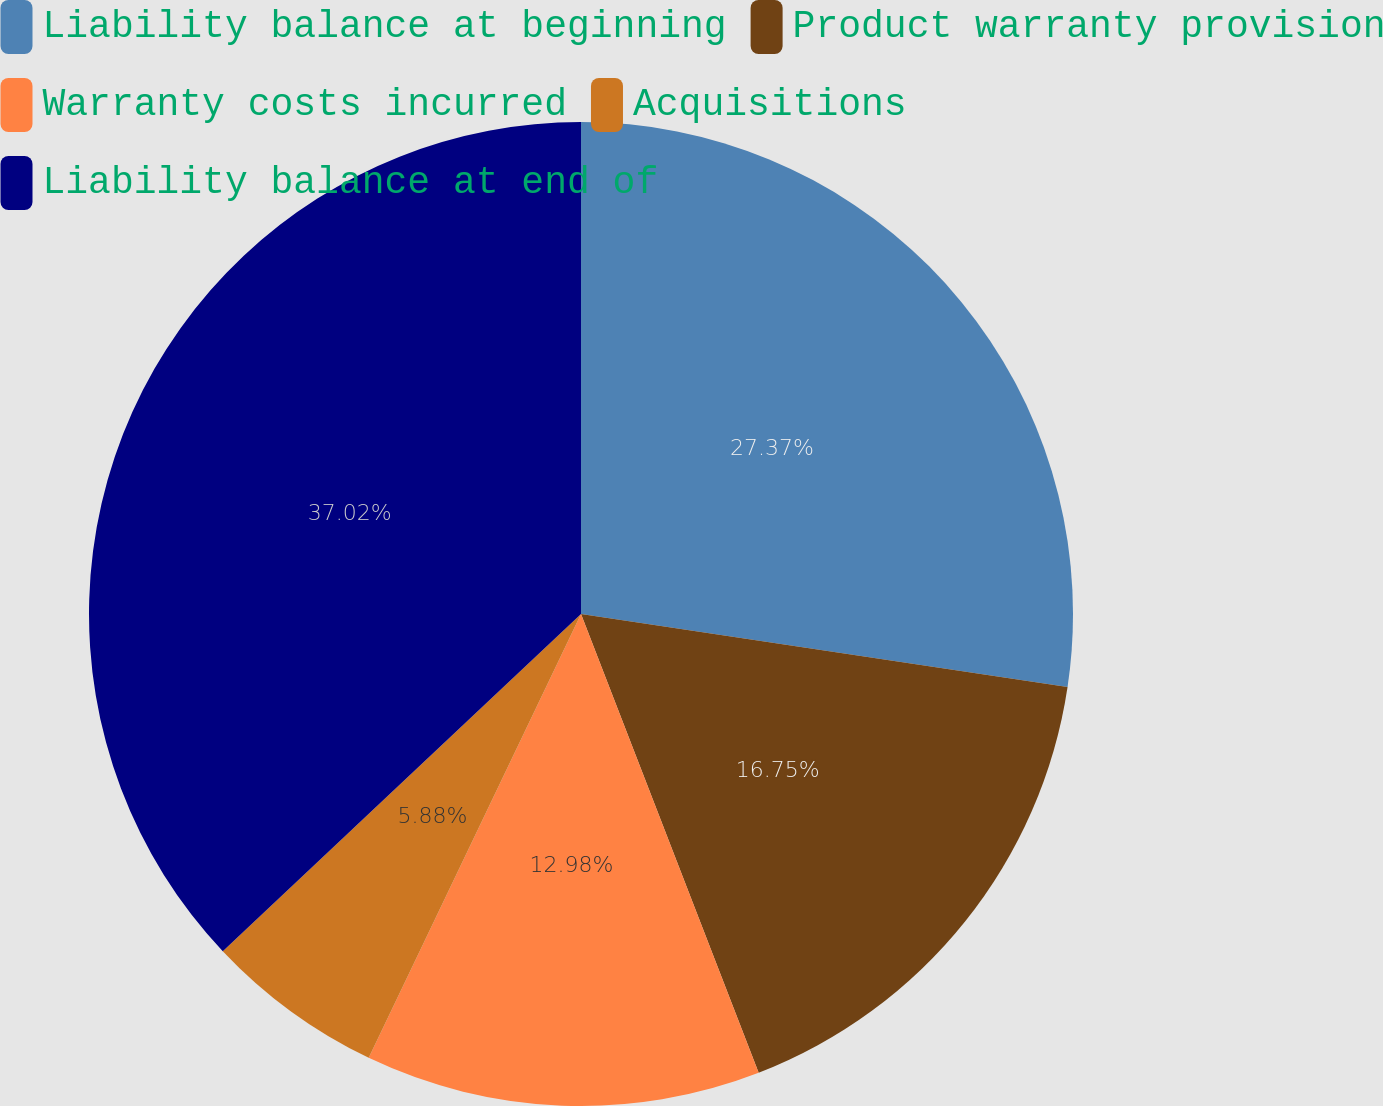Convert chart. <chart><loc_0><loc_0><loc_500><loc_500><pie_chart><fcel>Liability balance at beginning<fcel>Product warranty provision<fcel>Warranty costs incurred<fcel>Acquisitions<fcel>Liability balance at end of<nl><fcel>27.37%<fcel>16.75%<fcel>12.98%<fcel>5.88%<fcel>37.02%<nl></chart> 